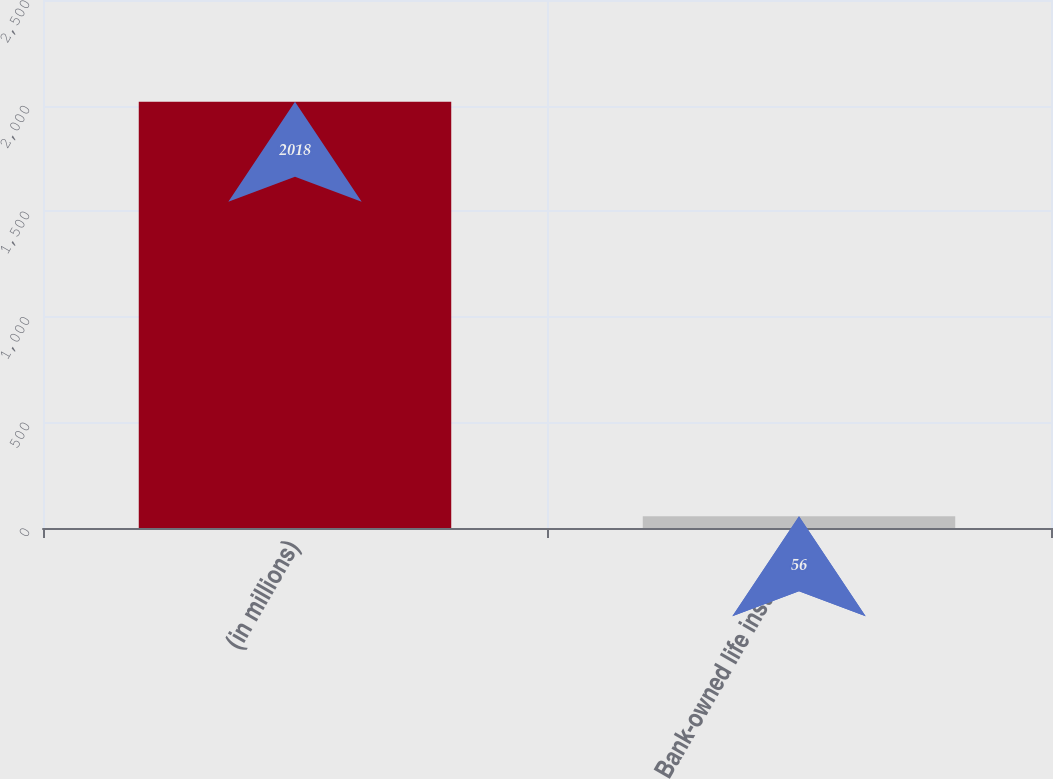Convert chart. <chart><loc_0><loc_0><loc_500><loc_500><bar_chart><fcel>(in millions)<fcel>Bank-owned life insurance<nl><fcel>2018<fcel>56<nl></chart> 